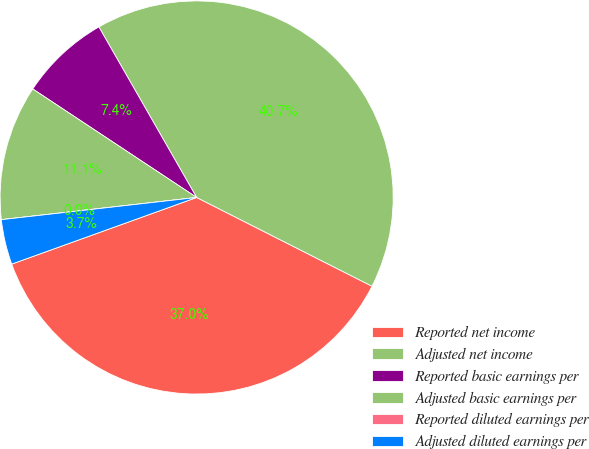Convert chart to OTSL. <chart><loc_0><loc_0><loc_500><loc_500><pie_chart><fcel>Reported net income<fcel>Adjusted net income<fcel>Reported basic earnings per<fcel>Adjusted basic earnings per<fcel>Reported diluted earnings per<fcel>Adjusted diluted earnings per<nl><fcel>37.04%<fcel>40.74%<fcel>7.41%<fcel>11.11%<fcel>0.0%<fcel>3.7%<nl></chart> 